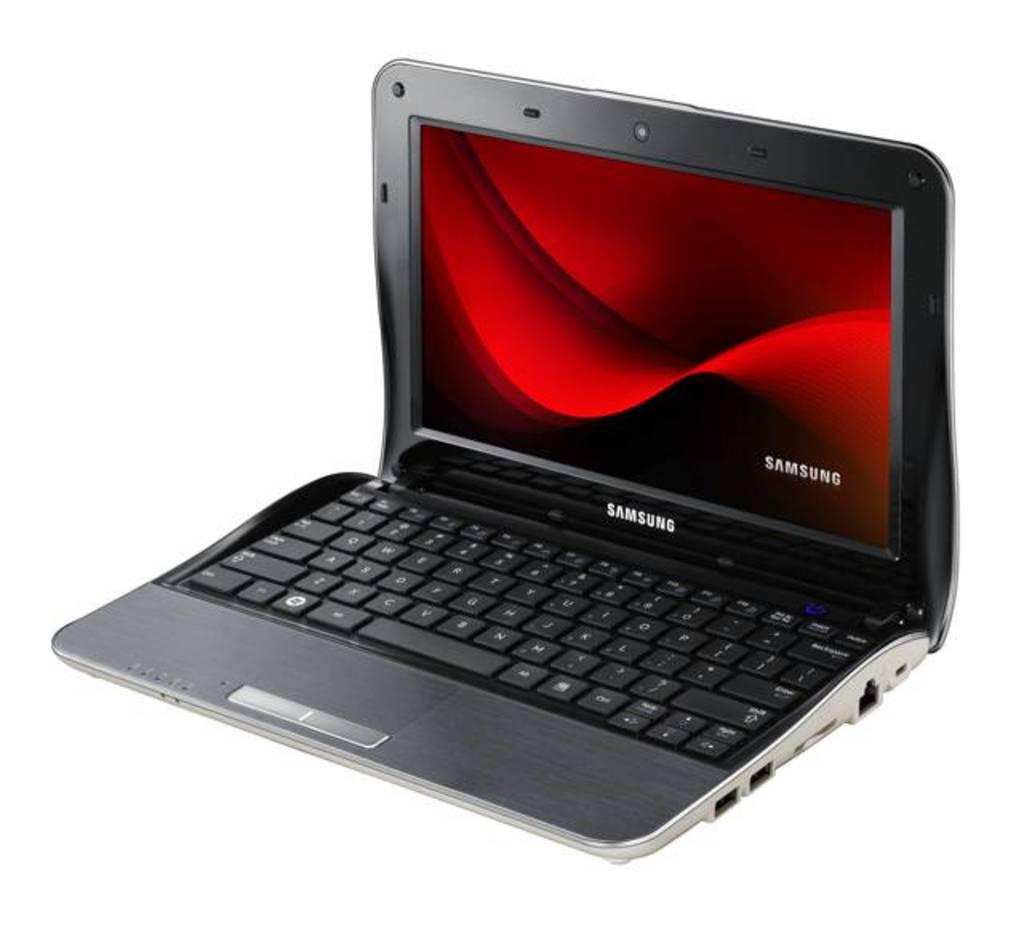<image>
Describe the image concisely. Samsung laptop metallic black with full keyboard with a red velvet background. 